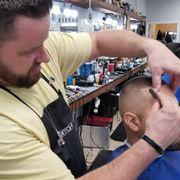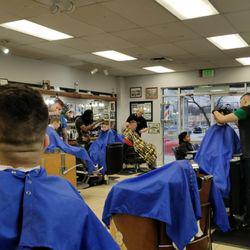The first image is the image on the left, the second image is the image on the right. For the images shown, is this caption "The left and right image contains the same number of barbers shaving and combing men with dark hair." true? Answer yes or no. No. The first image is the image on the left, the second image is the image on the right. For the images shown, is this caption "Each image shows a barber in the foreground working on the hair of a customer wearing a smock, and only one of the images shows a customer in a blue smock." true? Answer yes or no. No. 